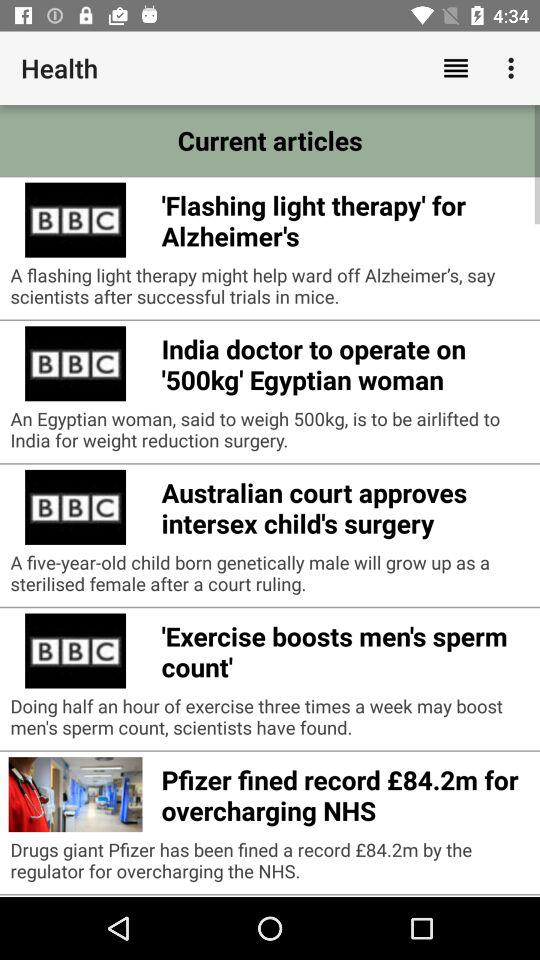What current articles are available? The available current articles are: "'Flashing light therapy' for Alzheimer's", "India doctor to operate on '500kg' Egyptian woman", "Australian court approves intersex child's surgery", "'Exercise boosts men's sperm count'", and "Pfizer fined record £84.2m for overcharging NHS". 